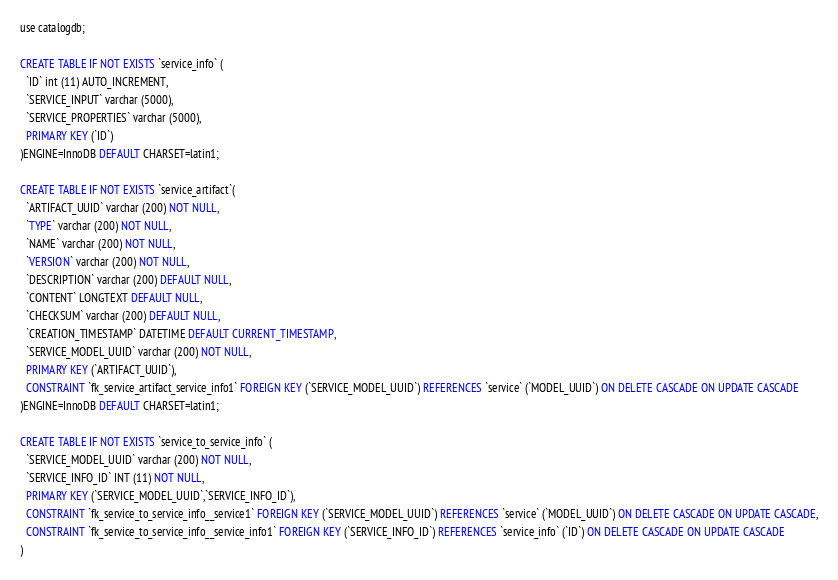<code> <loc_0><loc_0><loc_500><loc_500><_SQL_>use catalogdb;

CREATE TABLE IF NOT EXISTS `service_info` (
  `ID` int (11) AUTO_INCREMENT,
  `SERVICE_INPUT` varchar (5000),
  `SERVICE_PROPERTIES` varchar (5000),
  PRIMARY KEY (`ID`)
)ENGINE=InnoDB DEFAULT CHARSET=latin1;

CREATE TABLE IF NOT EXISTS `service_artifact`(
  `ARTIFACT_UUID` varchar (200) NOT NULL,
  `TYPE` varchar (200) NOT NULL,
  `NAME` varchar (200) NOT NULL,
  `VERSION` varchar (200) NOT NULL,
  `DESCRIPTION` varchar (200) DEFAULT NULL,
  `CONTENT` LONGTEXT DEFAULT NULL,
  `CHECKSUM` varchar (200) DEFAULT NULL,
  `CREATION_TIMESTAMP` DATETIME DEFAULT CURRENT_TIMESTAMP,
  `SERVICE_MODEL_UUID` varchar (200) NOT NULL,
  PRIMARY KEY (`ARTIFACT_UUID`),
  CONSTRAINT `fk_service_artifact_service_info1` FOREIGN KEY (`SERVICE_MODEL_UUID`) REFERENCES `service` (`MODEL_UUID`) ON DELETE CASCADE ON UPDATE CASCADE
)ENGINE=InnoDB DEFAULT CHARSET=latin1;

CREATE TABLE IF NOT EXISTS `service_to_service_info` (
  `SERVICE_MODEL_UUID` varchar (200) NOT NULL,
  `SERVICE_INFO_ID` INT (11) NOT NULL,
  PRIMARY KEY (`SERVICE_MODEL_UUID`,`SERVICE_INFO_ID`),
  CONSTRAINT `fk_service_to_service_info__service1` FOREIGN KEY (`SERVICE_MODEL_UUID`) REFERENCES `service` (`MODEL_UUID`) ON DELETE CASCADE ON UPDATE CASCADE,
  CONSTRAINT `fk_service_to_service_info__service_info1` FOREIGN KEY (`SERVICE_INFO_ID`) REFERENCES `service_info` (`ID`) ON DELETE CASCADE ON UPDATE CASCADE
)</code> 